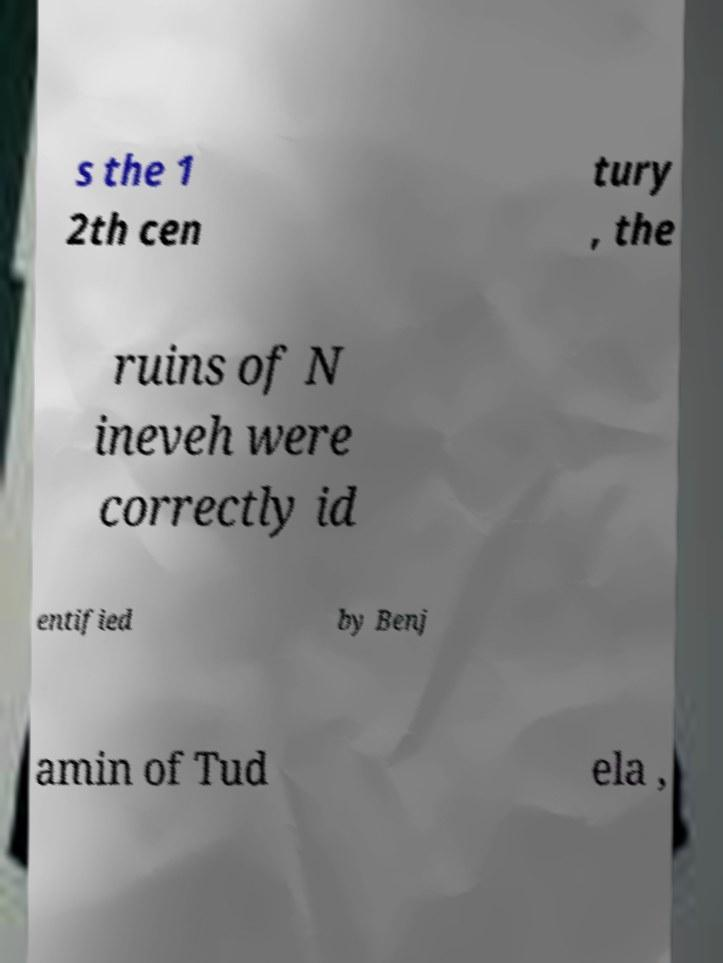Could you assist in decoding the text presented in this image and type it out clearly? s the 1 2th cen tury , the ruins of N ineveh were correctly id entified by Benj amin of Tud ela , 